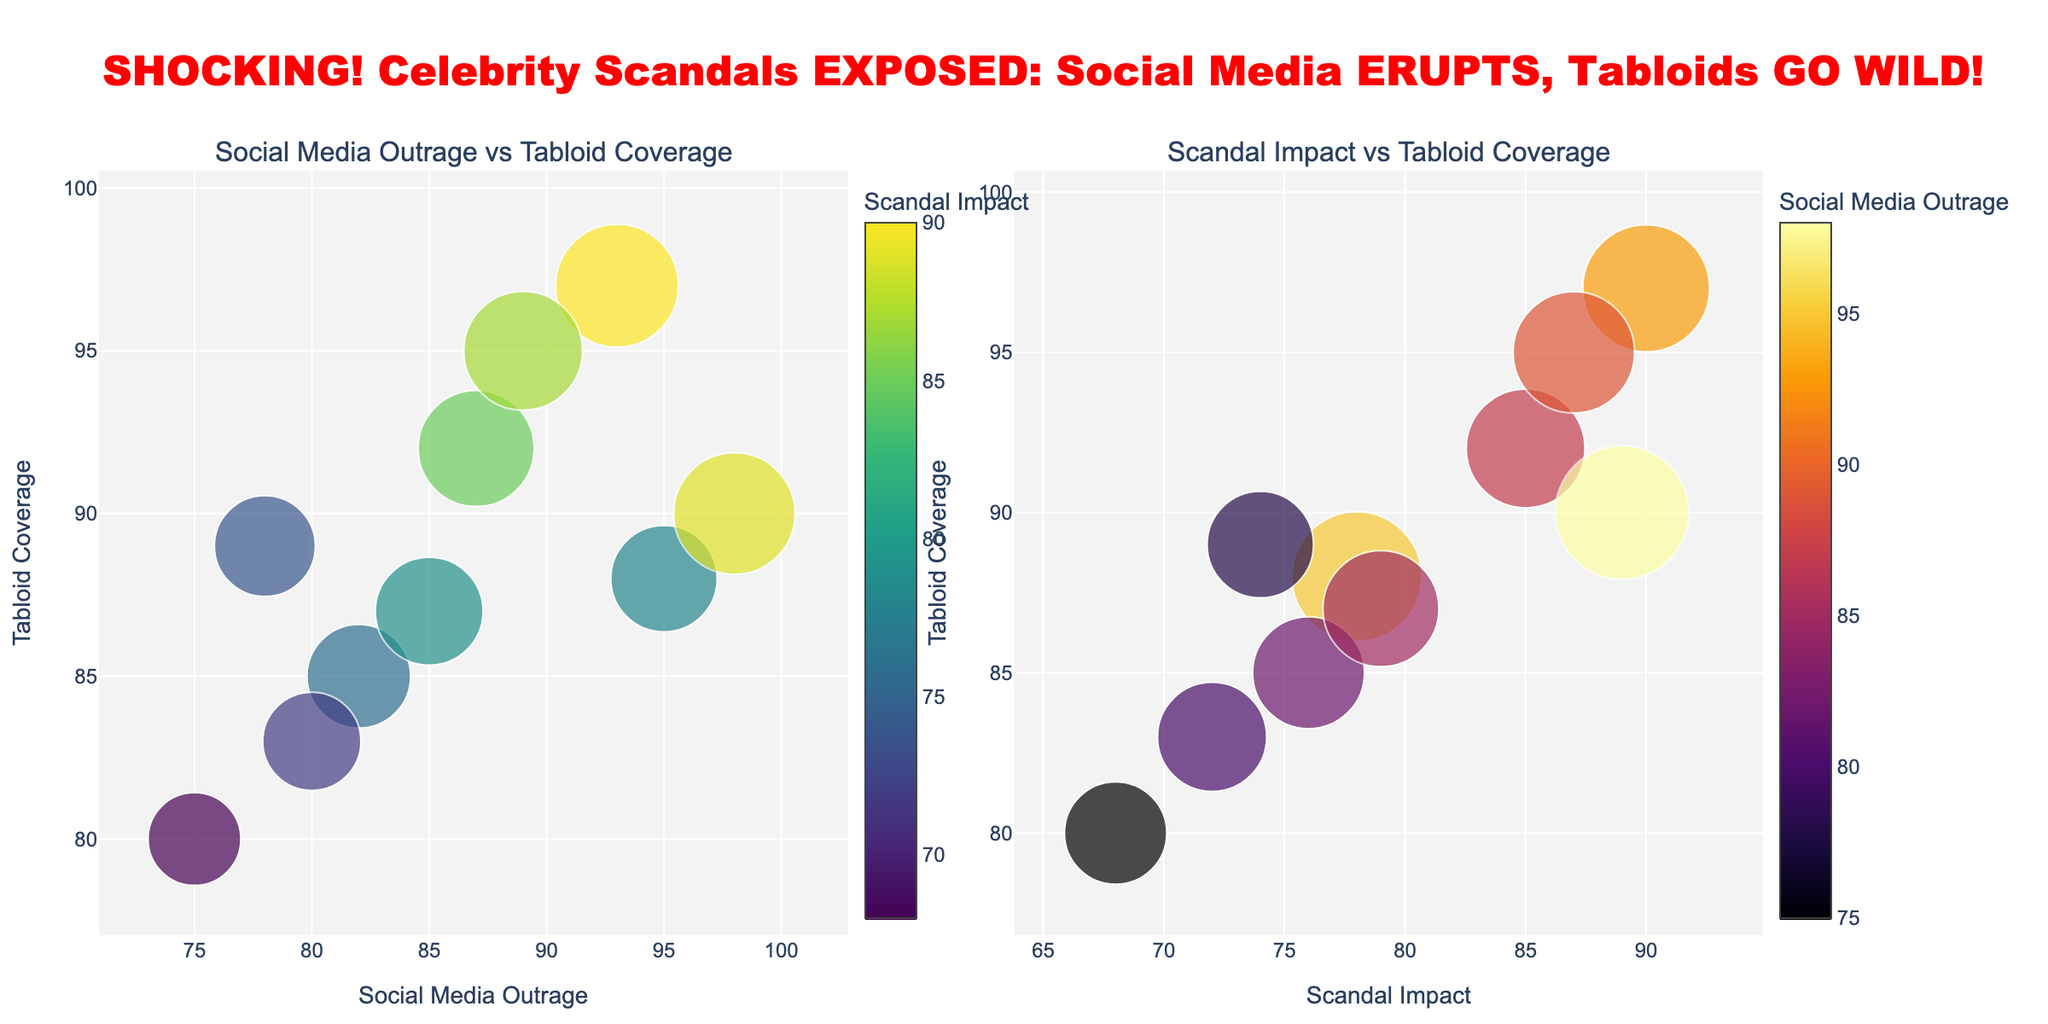How many total celebrities are included in the figure? The figure shows one bubble per celebrity, so by counting the number of bubbles in either chart, you can determine the total number of celebrities.
Answer: 10 Which celebrity has the highest social media outrage? In the "Social Media Outrage vs Tabloid Coverage" chart, look for the bubble located farthest to the right on the horizontal axis.
Answer: Kanye West Which scandal had the highest combined outrage (social media and tabloid) and impact? Sum the values of social media outrage, tabloid coverage, and scandal impact for each celebrity. The highest combined value is the target. Kanye West: (98+90+89=277), Tiger Woods: (89+95+87=271). Kanye has the highest combined value.
Answer: Kanye West Who has a higher social media outrage: Kim Kardashian or Tiger Woods? Compare the horizontal positions of the bubbles for Kim Kardashian and Tiger Woods in the "Social Media Outrage vs Tabloid Coverage" chart.
Answer: Kim Kardashian What is the average Scandal Impact? Look at the colorbar in the "Social Media Outrage vs Tabloid Coverage" chart to estimate each scandal impact value, then calculate the average: (78 + 85 + 90 + 76 + 89 + 68 + 87 + 72 + 79 + 74) / 10 = 79.8.
Answer: 79.8 Which scandal has a greater impact: Johnny Depp or Charlie Sheen? In the "Scandal Impact vs Tabloid Coverage" chart, compare the horizontal position of the bubbles for Johnny Depp and Charlie Sheen.
Answer: Johnny Depp Is there any celebrity with tabloid coverage lower than 80? Check both charts for any bubble below the horizontal 80 line on the vertical axis. No bubbles are below this line, meaning no coverage is less than 80.
Answer: No Which celebrity has the smallest bubble in the "Social Media Outrage vs Tabloid Coverage" chart? In this chart, the bubble size corresponds to the scandal impact. The smallest bubble size is for the lowest scandal impact value, which belongs to Lindsay Lohan.
Answer: Lindsay Lohan What are the colors indicating in the "Scandal Impact vs Tabloid Coverage" chart? The color scale on the right side of this chart indicates the varying levels of social media outrage. Darker colors represent higher outrage.
Answer: Social media outrage 